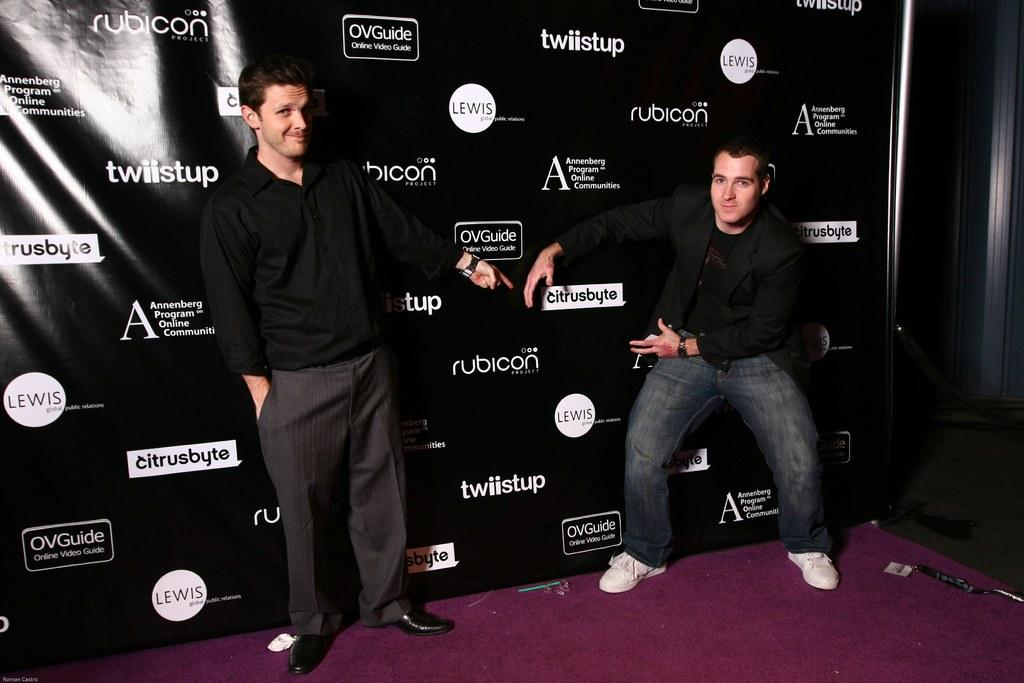How many people are in the foreground of the image? There are two men in the foreground of the image. What are the men doing in the image? The men are standing on a stage. What else can be seen in the image besides the men? There is a banner wall present in the image. What type of scarf is the doctor wearing in the image? There is no doctor or scarf present in the image. What play are the men performing on the stage in the image? The image does not provide information about a play or the men's performance. 